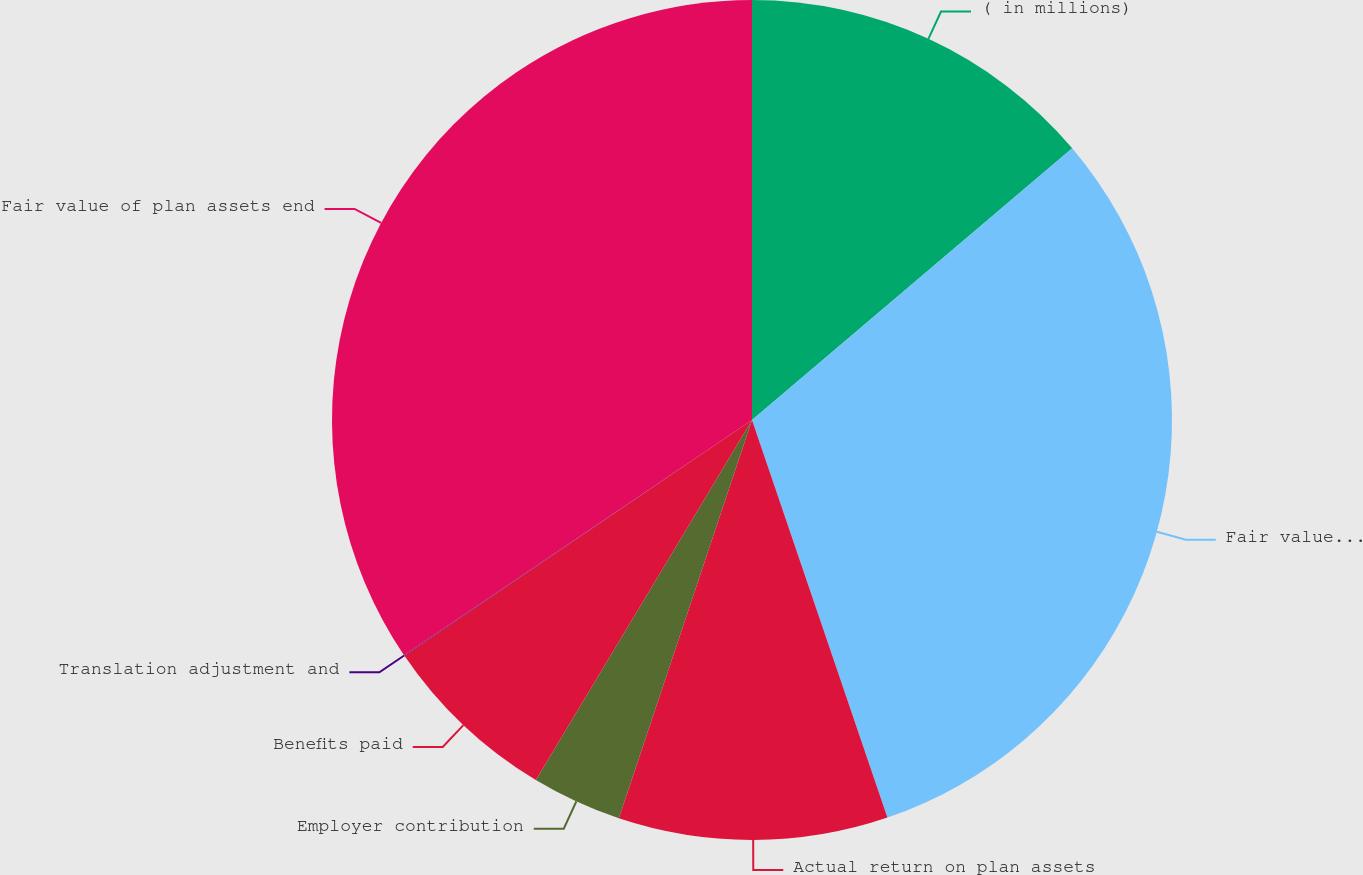Convert chart. <chart><loc_0><loc_0><loc_500><loc_500><pie_chart><fcel>( in millions)<fcel>Fair value of plan assets<fcel>Actual return on plan assets<fcel>Employer contribution<fcel>Benefits paid<fcel>Translation adjustment and<fcel>Fair value of plan assets end<nl><fcel>13.8%<fcel>30.98%<fcel>10.36%<fcel>3.47%<fcel>6.91%<fcel>0.03%<fcel>34.46%<nl></chart> 